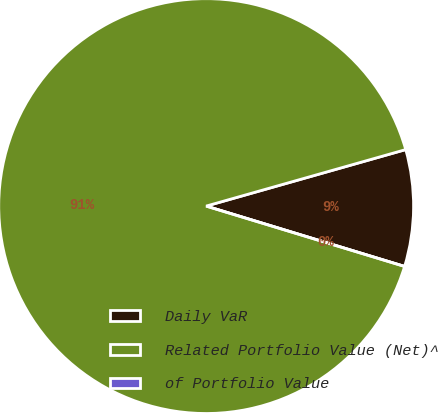Convert chart. <chart><loc_0><loc_0><loc_500><loc_500><pie_chart><fcel>Daily VaR<fcel>Related Portfolio Value (Net)^<fcel>of Portfolio Value<nl><fcel>9.09%<fcel>90.91%<fcel>0.0%<nl></chart> 